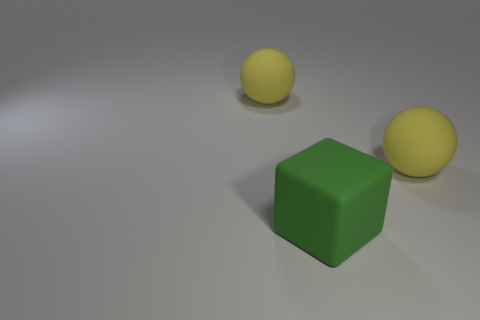Add 1 large objects. How many objects exist? 4 Subtract all balls. How many objects are left? 1 Subtract 2 spheres. How many spheres are left? 0 Add 1 green matte things. How many green matte things exist? 2 Subtract 0 red spheres. How many objects are left? 3 Subtract all gray balls. Subtract all blue cylinders. How many balls are left? 2 Subtract all yellow matte balls. Subtract all large green cubes. How many objects are left? 0 Add 3 big rubber things. How many big rubber things are left? 6 